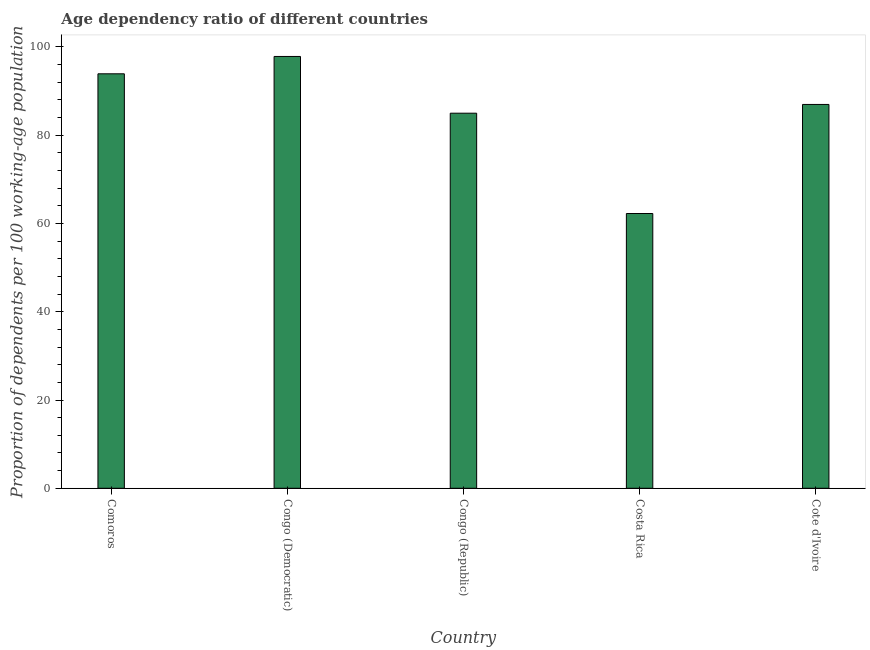What is the title of the graph?
Offer a very short reply. Age dependency ratio of different countries. What is the label or title of the Y-axis?
Keep it short and to the point. Proportion of dependents per 100 working-age population. What is the age dependency ratio in Costa Rica?
Make the answer very short. 62.25. Across all countries, what is the maximum age dependency ratio?
Provide a short and direct response. 97.83. Across all countries, what is the minimum age dependency ratio?
Give a very brief answer. 62.25. In which country was the age dependency ratio maximum?
Offer a very short reply. Congo (Democratic). In which country was the age dependency ratio minimum?
Provide a short and direct response. Costa Rica. What is the sum of the age dependency ratio?
Ensure brevity in your answer.  425.91. What is the difference between the age dependency ratio in Comoros and Cote d'Ivoire?
Your answer should be compact. 6.94. What is the average age dependency ratio per country?
Keep it short and to the point. 85.18. What is the median age dependency ratio?
Your response must be concise. 86.96. What is the ratio of the age dependency ratio in Comoros to that in Costa Rica?
Provide a succinct answer. 1.51. Is the difference between the age dependency ratio in Comoros and Congo (Democratic) greater than the difference between any two countries?
Provide a succinct answer. No. What is the difference between the highest and the second highest age dependency ratio?
Keep it short and to the point. 3.93. Is the sum of the age dependency ratio in Congo (Republic) and Cote d'Ivoire greater than the maximum age dependency ratio across all countries?
Provide a short and direct response. Yes. What is the difference between the highest and the lowest age dependency ratio?
Offer a very short reply. 35.58. In how many countries, is the age dependency ratio greater than the average age dependency ratio taken over all countries?
Offer a very short reply. 3. Are all the bars in the graph horizontal?
Your answer should be compact. No. How many countries are there in the graph?
Offer a very short reply. 5. What is the difference between two consecutive major ticks on the Y-axis?
Your answer should be very brief. 20. What is the Proportion of dependents per 100 working-age population in Comoros?
Offer a very short reply. 93.9. What is the Proportion of dependents per 100 working-age population of Congo (Democratic)?
Keep it short and to the point. 97.83. What is the Proportion of dependents per 100 working-age population in Congo (Republic)?
Provide a short and direct response. 84.98. What is the Proportion of dependents per 100 working-age population of Costa Rica?
Ensure brevity in your answer.  62.25. What is the Proportion of dependents per 100 working-age population in Cote d'Ivoire?
Your response must be concise. 86.96. What is the difference between the Proportion of dependents per 100 working-age population in Comoros and Congo (Democratic)?
Provide a succinct answer. -3.93. What is the difference between the Proportion of dependents per 100 working-age population in Comoros and Congo (Republic)?
Keep it short and to the point. 8.92. What is the difference between the Proportion of dependents per 100 working-age population in Comoros and Costa Rica?
Make the answer very short. 31.65. What is the difference between the Proportion of dependents per 100 working-age population in Comoros and Cote d'Ivoire?
Your response must be concise. 6.94. What is the difference between the Proportion of dependents per 100 working-age population in Congo (Democratic) and Congo (Republic)?
Ensure brevity in your answer.  12.85. What is the difference between the Proportion of dependents per 100 working-age population in Congo (Democratic) and Costa Rica?
Provide a succinct answer. 35.58. What is the difference between the Proportion of dependents per 100 working-age population in Congo (Democratic) and Cote d'Ivoire?
Offer a terse response. 10.87. What is the difference between the Proportion of dependents per 100 working-age population in Congo (Republic) and Costa Rica?
Provide a short and direct response. 22.73. What is the difference between the Proportion of dependents per 100 working-age population in Congo (Republic) and Cote d'Ivoire?
Your answer should be compact. -1.98. What is the difference between the Proportion of dependents per 100 working-age population in Costa Rica and Cote d'Ivoire?
Provide a short and direct response. -24.71. What is the ratio of the Proportion of dependents per 100 working-age population in Comoros to that in Congo (Republic)?
Provide a short and direct response. 1.1. What is the ratio of the Proportion of dependents per 100 working-age population in Comoros to that in Costa Rica?
Ensure brevity in your answer.  1.51. What is the ratio of the Proportion of dependents per 100 working-age population in Congo (Democratic) to that in Congo (Republic)?
Provide a short and direct response. 1.15. What is the ratio of the Proportion of dependents per 100 working-age population in Congo (Democratic) to that in Costa Rica?
Offer a very short reply. 1.57. What is the ratio of the Proportion of dependents per 100 working-age population in Congo (Democratic) to that in Cote d'Ivoire?
Offer a very short reply. 1.12. What is the ratio of the Proportion of dependents per 100 working-age population in Congo (Republic) to that in Costa Rica?
Your answer should be very brief. 1.36. What is the ratio of the Proportion of dependents per 100 working-age population in Costa Rica to that in Cote d'Ivoire?
Provide a short and direct response. 0.72. 